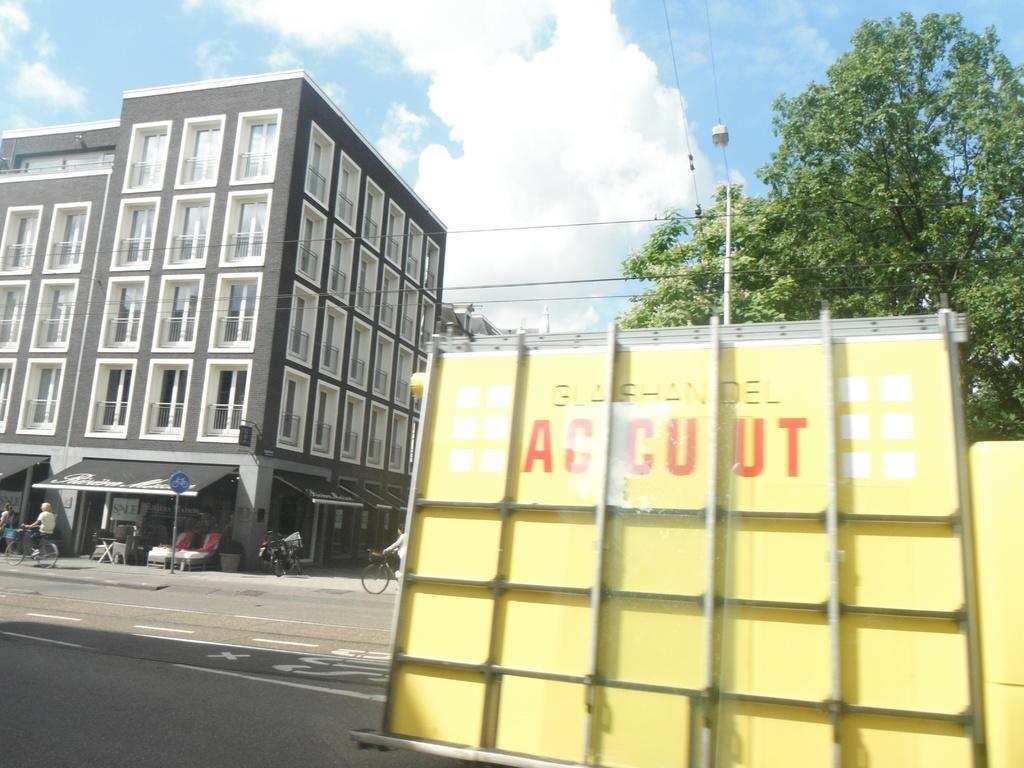Please provide a concise description of this image. In this picture, it seems like a vehicle in the foreground area of the image, there are people, stalls, buildings, trees and the sky in the background. 